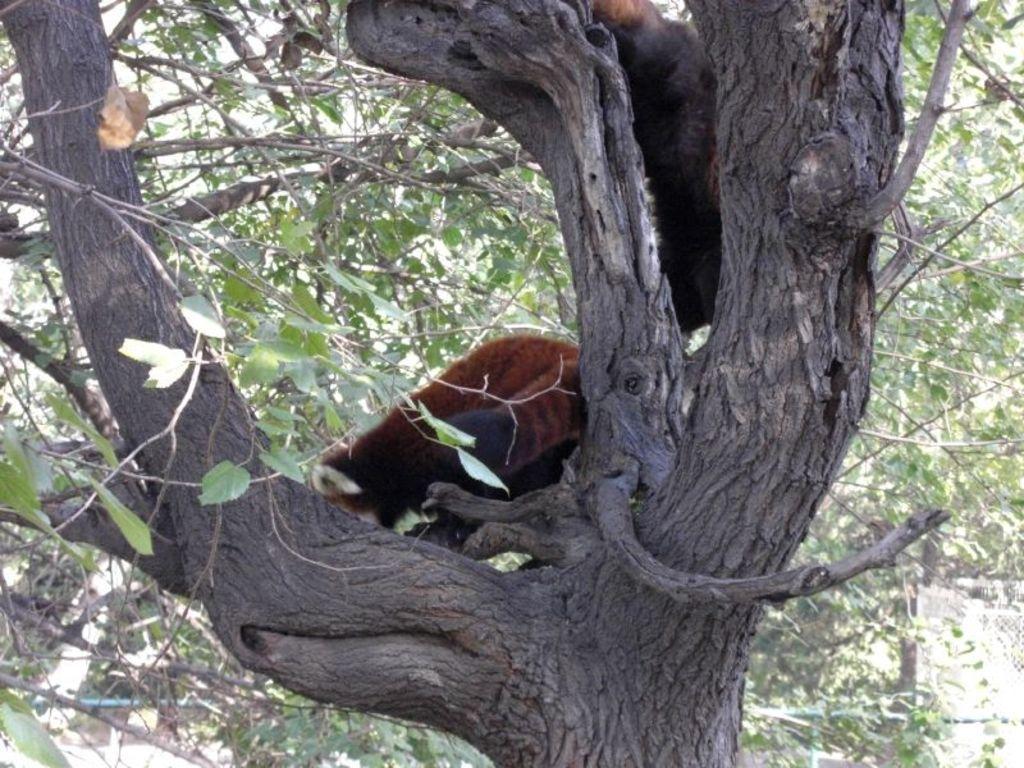Can you describe this image briefly? In this image I can see a tree which is ash in color and on the tree I can see two things which are brown and black in color. To the bottom of the image I can see the ground and few other objects. 